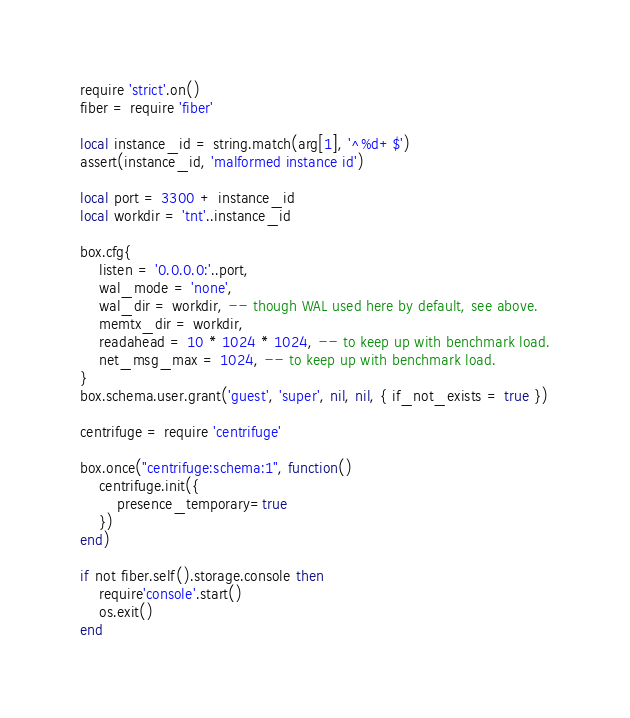<code> <loc_0><loc_0><loc_500><loc_500><_Lua_>require 'strict'.on()
fiber = require 'fiber'

local instance_id = string.match(arg[1], '^%d+$')
assert(instance_id, 'malformed instance id')

local port = 3300 + instance_id
local workdir = 'tnt'..instance_id

box.cfg{
    listen = '0.0.0.0:'..port,
    wal_mode = 'none',
    wal_dir = workdir, -- though WAL used here by default, see above.
    memtx_dir = workdir,
    readahead = 10 * 1024 * 1024, -- to keep up with benchmark load.
    net_msg_max = 1024, -- to keep up with benchmark load.
}
box.schema.user.grant('guest', 'super', nil, nil, { if_not_exists = true })

centrifuge = require 'centrifuge'

box.once("centrifuge:schema:1", function()
    centrifuge.init({
        presence_temporary=true
    })
end)

if not fiber.self().storage.console then
    require'console'.start()
    os.exit()
end
</code> 